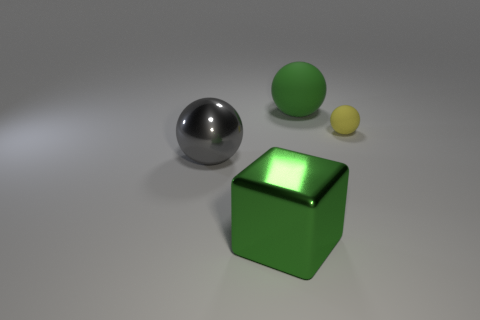Add 1 yellow balls. How many objects exist? 5 Subtract all balls. How many objects are left? 1 Add 1 green rubber balls. How many green rubber balls are left? 2 Add 1 metallic things. How many metallic things exist? 3 Subtract 0 red balls. How many objects are left? 4 Subtract all big brown metal cylinders. Subtract all large metallic spheres. How many objects are left? 3 